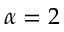Convert formula to latex. <formula><loc_0><loc_0><loc_500><loc_500>\alpha = 2</formula> 